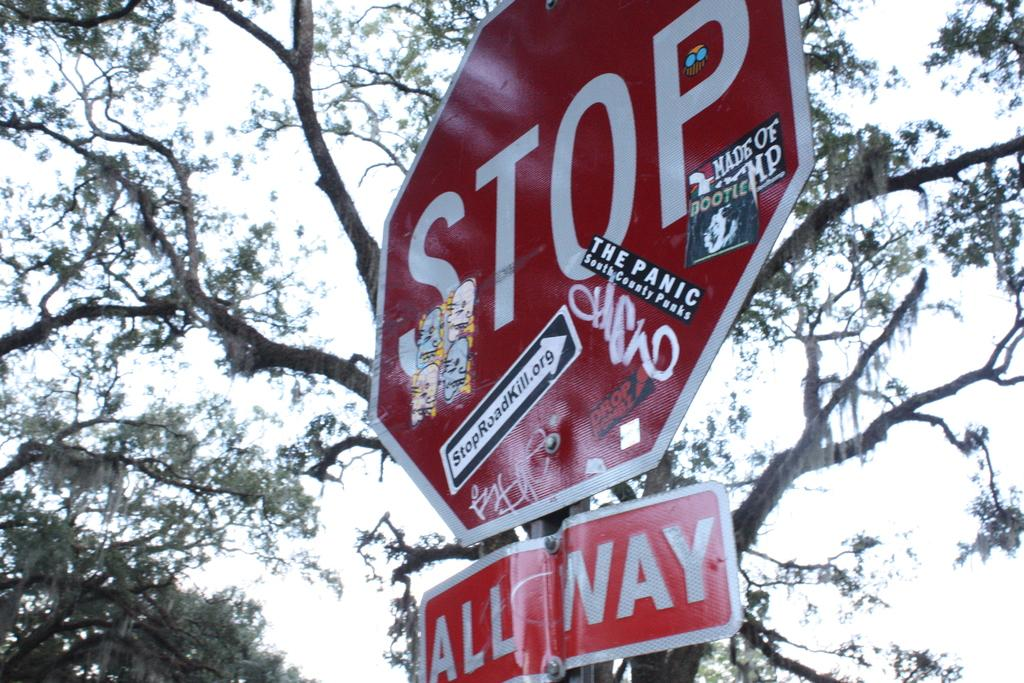Provide a one-sentence caption for the provided image. A stop sign plastered with various stickers stands below a tree. 